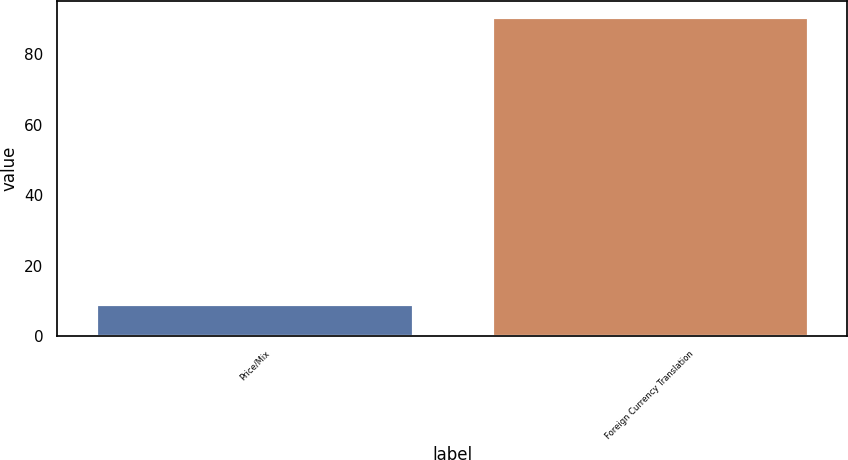Convert chart to OTSL. <chart><loc_0><loc_0><loc_500><loc_500><bar_chart><fcel>Price/Mix<fcel>Foreign Currency Translation<nl><fcel>9.1<fcel>90.5<nl></chart> 